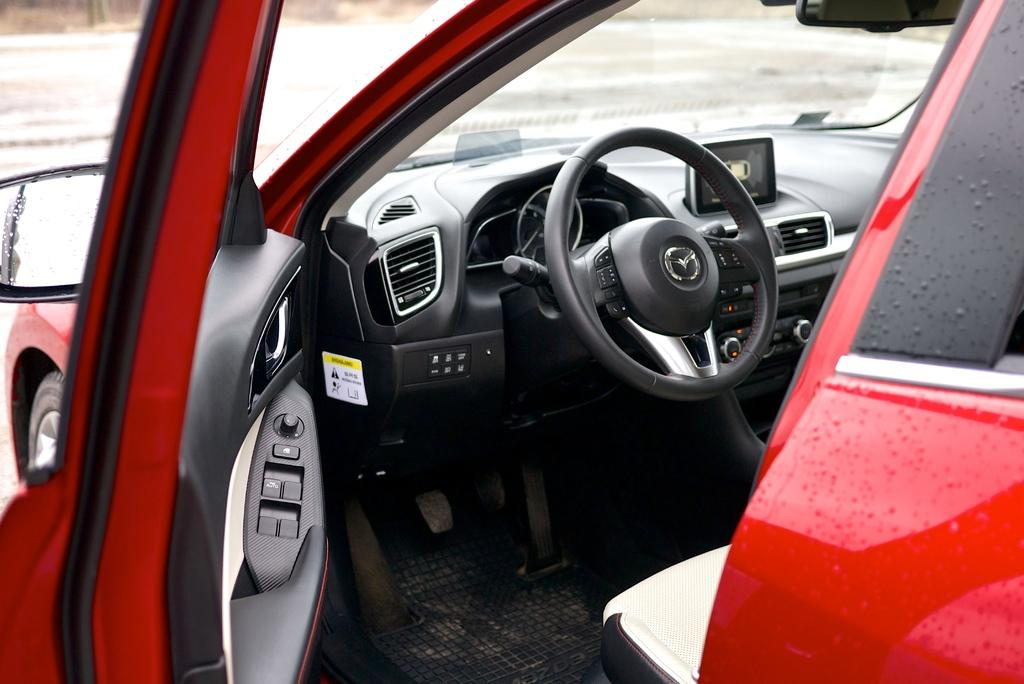What is the main subject of the image? The main subject of the image is a car. What is the state of the car door in the image? The car door is opened in the image. What is used for steering the car? There is a steering wheel in the car. What feature is present for controlling the temperature inside the car? There is an air conditioning system (AC) in the car. What type of controls are present in the car? There are buttons in the car. What type of dinner is being served on the beds in the image? There are no beds or dinner present in the image; it features a car with an opened door. Can you hear a whistle in the background of the image? There is no whistle or any sound mentioned in the image; it only provides visual information. 